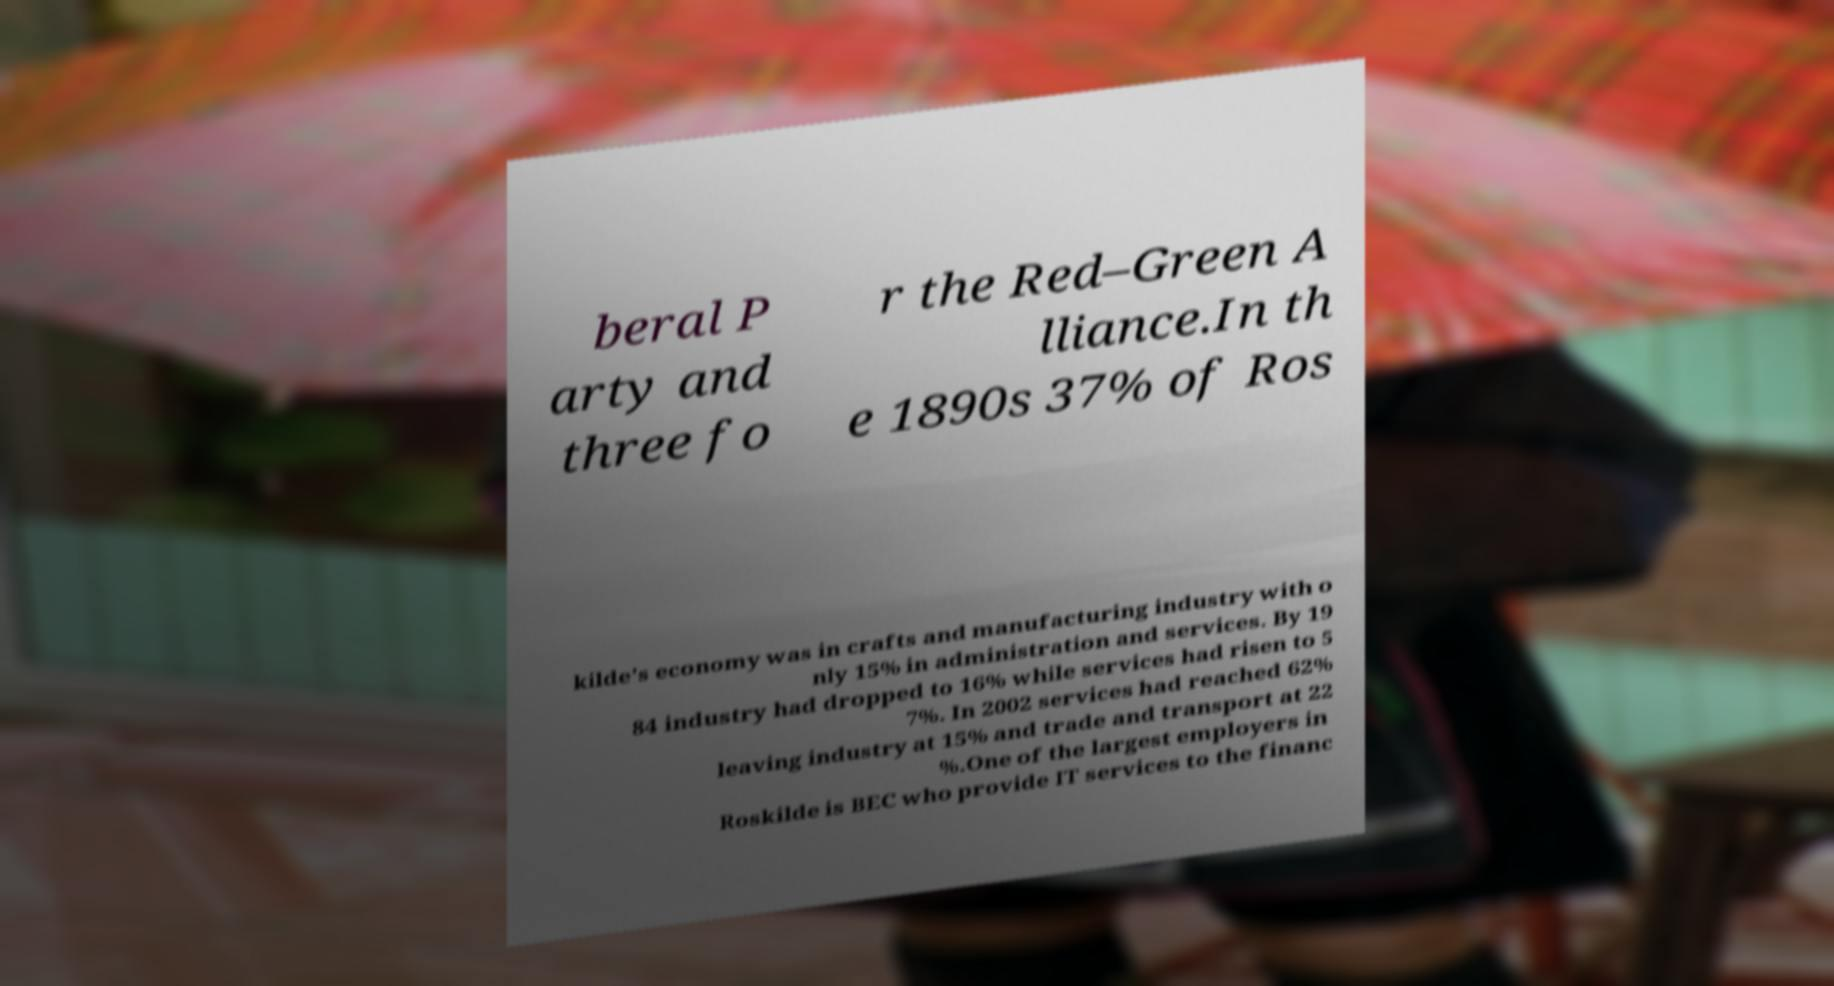Can you read and provide the text displayed in the image?This photo seems to have some interesting text. Can you extract and type it out for me? beral P arty and three fo r the Red–Green A lliance.In th e 1890s 37% of Ros kilde's economy was in crafts and manufacturing industry with o nly 15% in administration and services. By 19 84 industry had dropped to 16% while services had risen to 5 7%. In 2002 services had reached 62% leaving industry at 15% and trade and transport at 22 %.One of the largest employers in Roskilde is BEC who provide IT services to the financ 